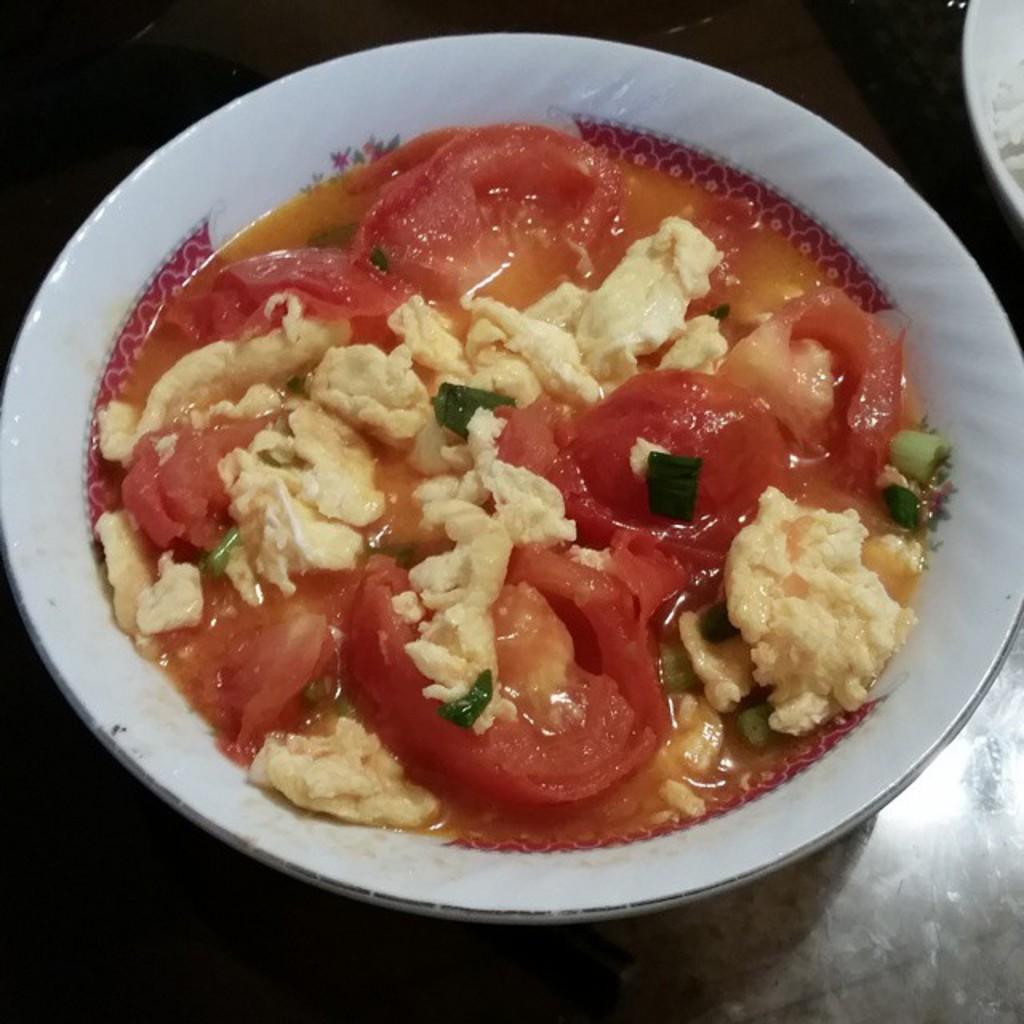How would you summarize this image in a sentence or two? In the foreground of this image, there is vegetable soup in a bowl on a black surface. At the top right, there is white color object. 